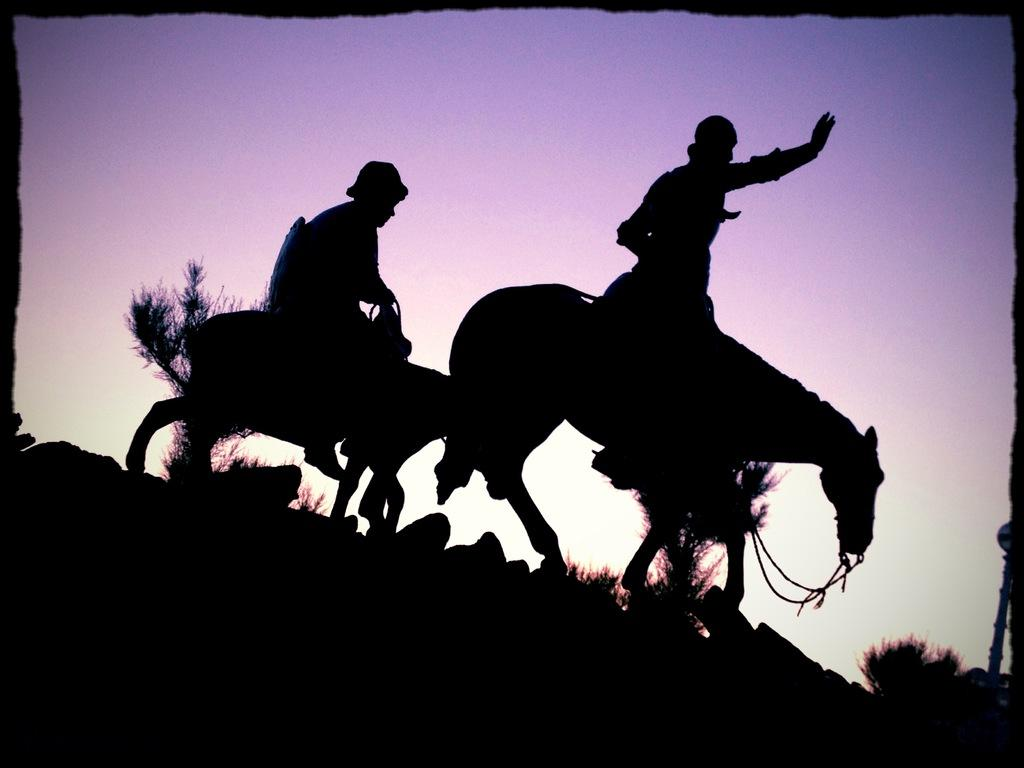How many people are in the image? There are two persons in the image. What are the persons doing in the image? The persons are riding horses. What type of natural environment is visible in the image? There are trees in the image, suggesting a natural setting. What can be seen in the background of the image? The sky is visible in the background of the image. Where is the mailbox located in the image? There is no mailbox present in the image. What type of grip do the horses have on the skate in the image? There is no skate present in the image, and the horses are not shown gripping anything. 